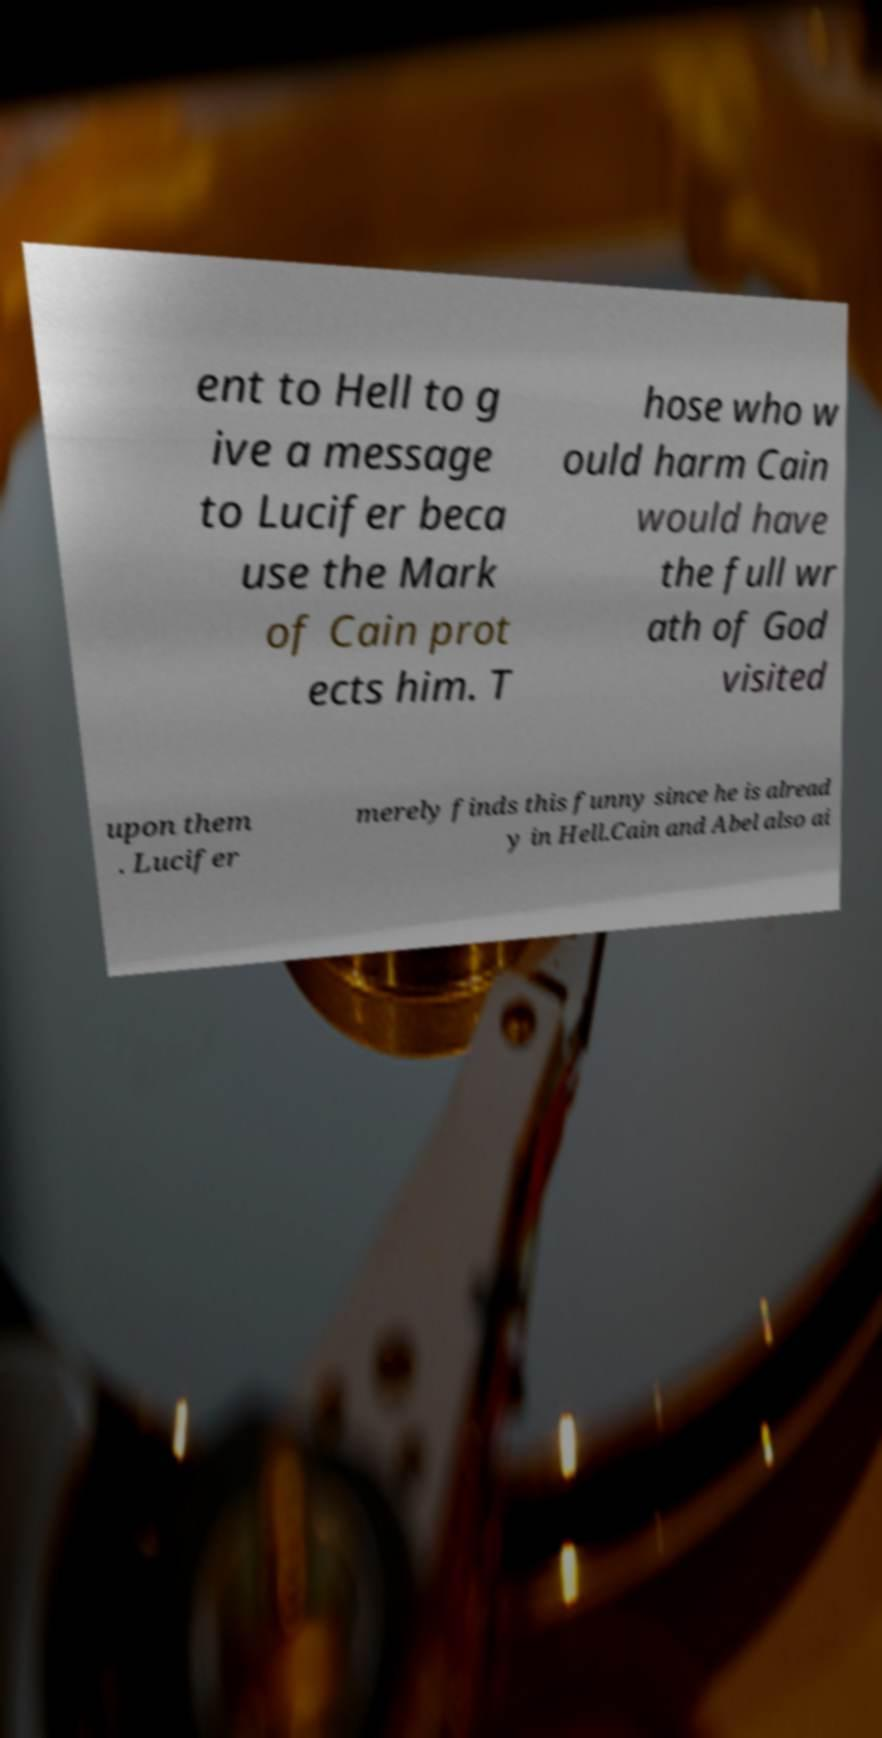For documentation purposes, I need the text within this image transcribed. Could you provide that? ent to Hell to g ive a message to Lucifer beca use the Mark of Cain prot ects him. T hose who w ould harm Cain would have the full wr ath of God visited upon them . Lucifer merely finds this funny since he is alread y in Hell.Cain and Abel also ai 